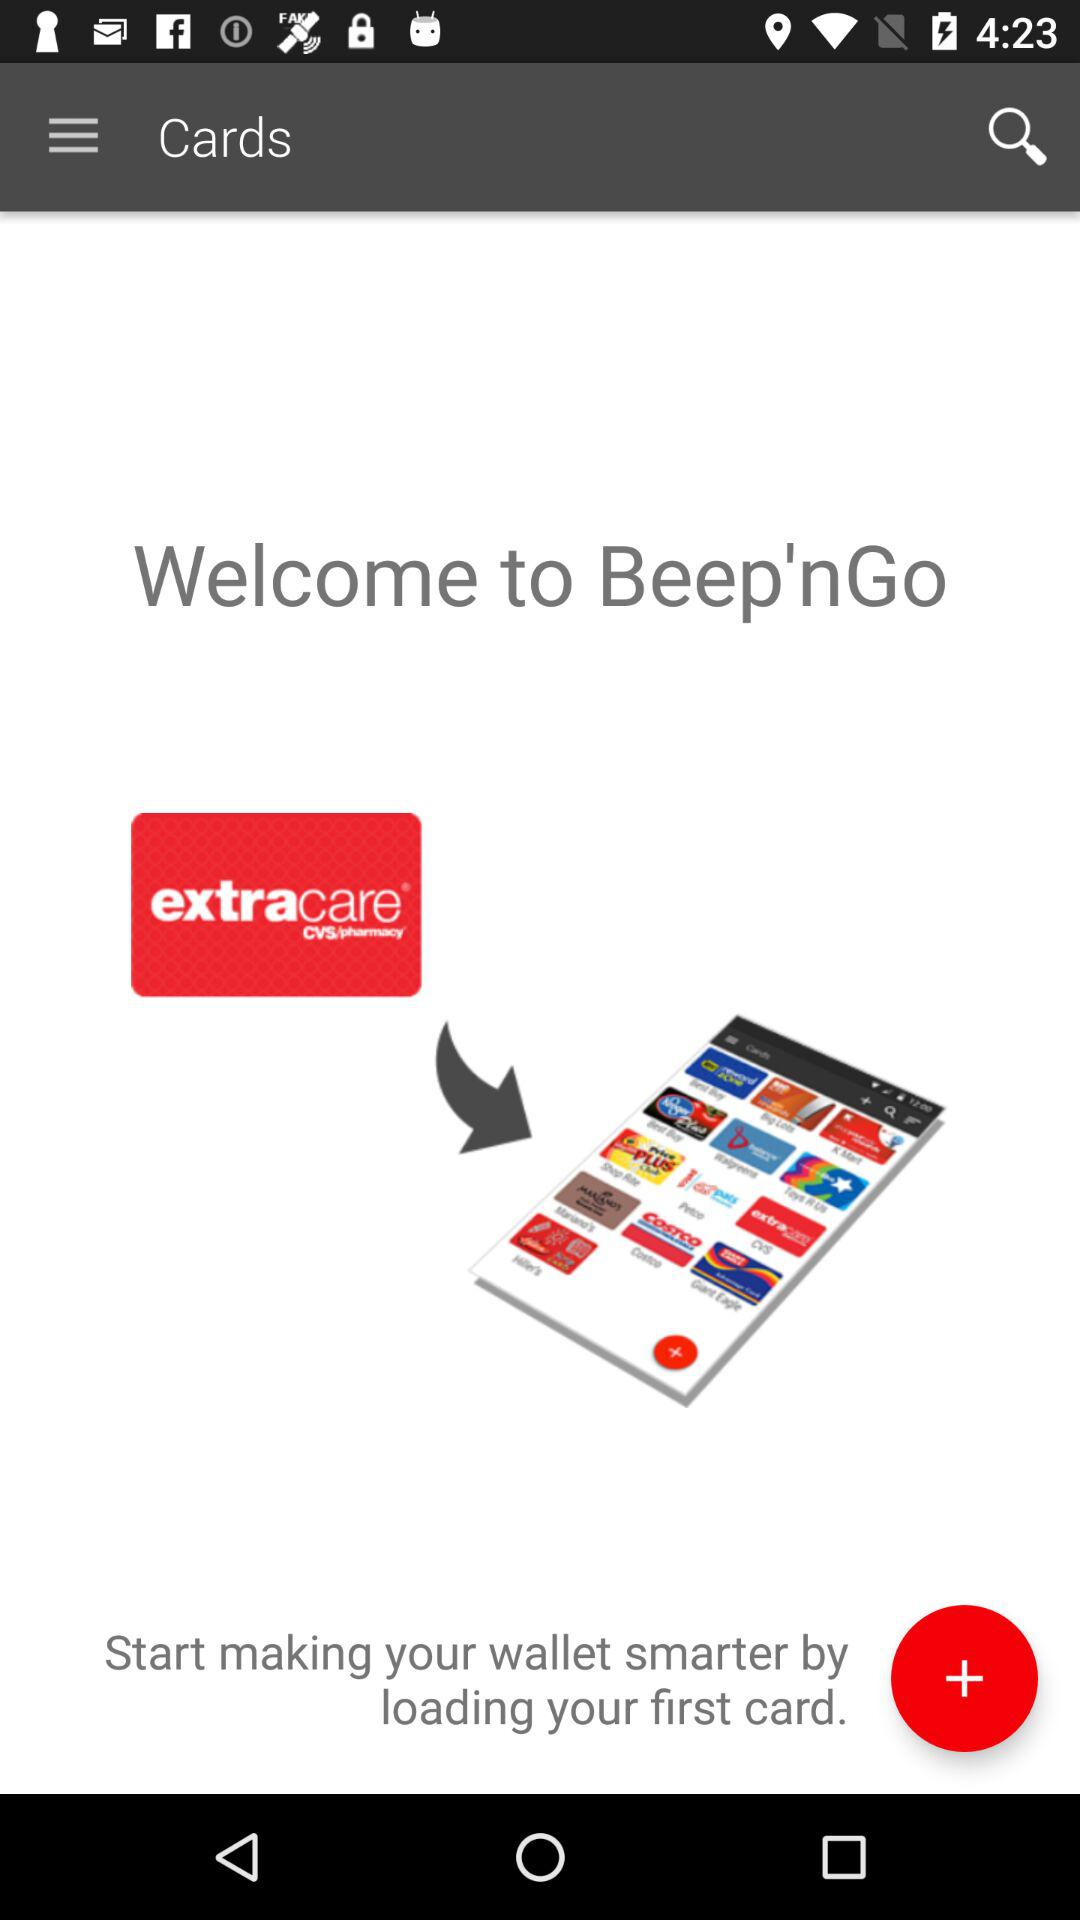What is the application name? The application name is "Beep'nGO". 